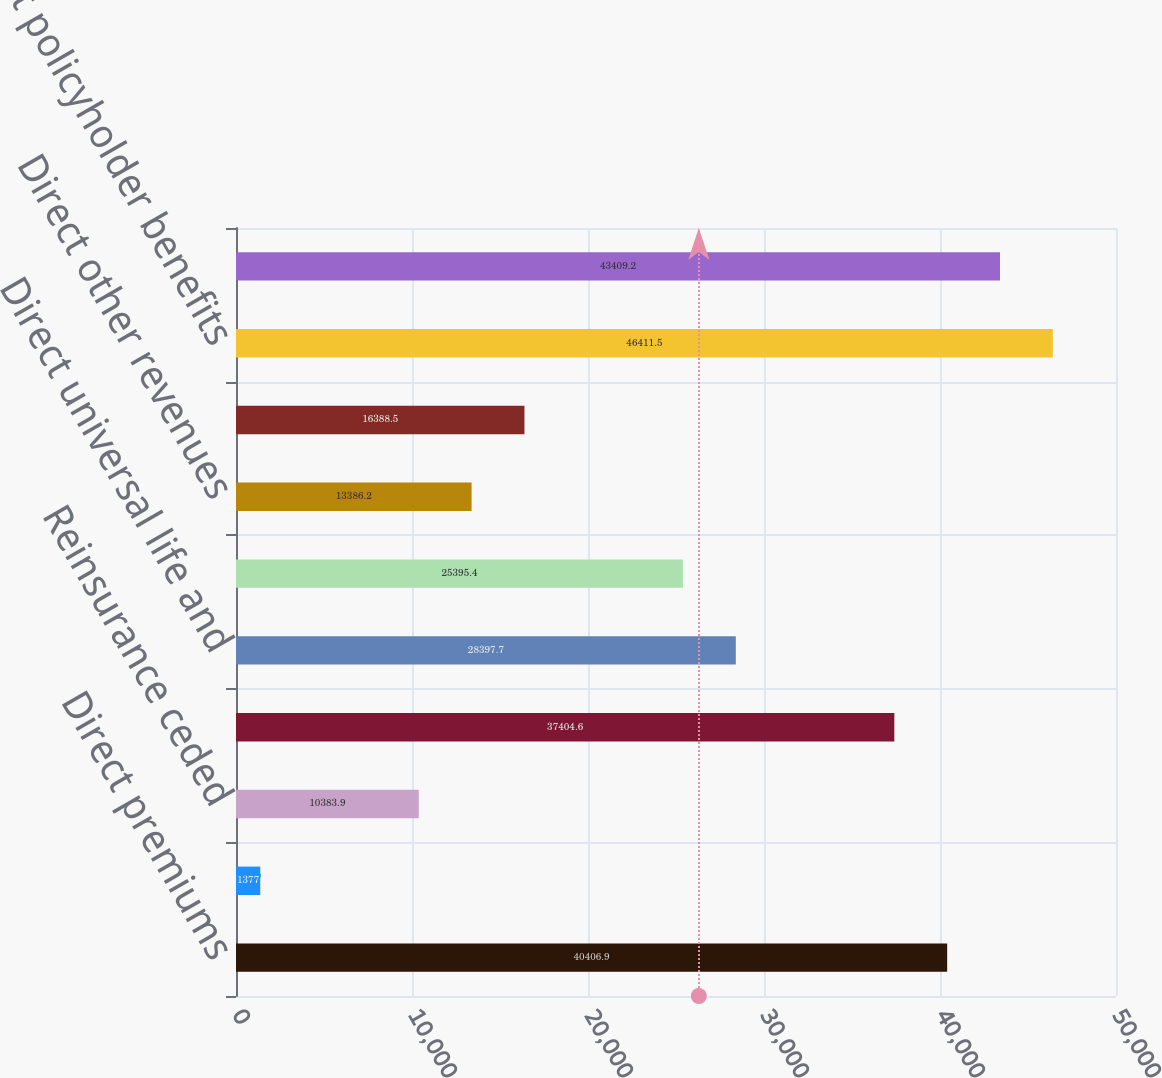Convert chart. <chart><loc_0><loc_0><loc_500><loc_500><bar_chart><fcel>Direct premiums<fcel>Reinsurance assumed<fcel>Reinsurance ceded<fcel>Net premiums<fcel>Direct universal life and<fcel>Net universal life and<fcel>Direct other revenues<fcel>Net other revenues<fcel>Direct policyholder benefits<fcel>Net policyholder benefits and<nl><fcel>40406.9<fcel>1377<fcel>10383.9<fcel>37404.6<fcel>28397.7<fcel>25395.4<fcel>13386.2<fcel>16388.5<fcel>46411.5<fcel>43409.2<nl></chart> 